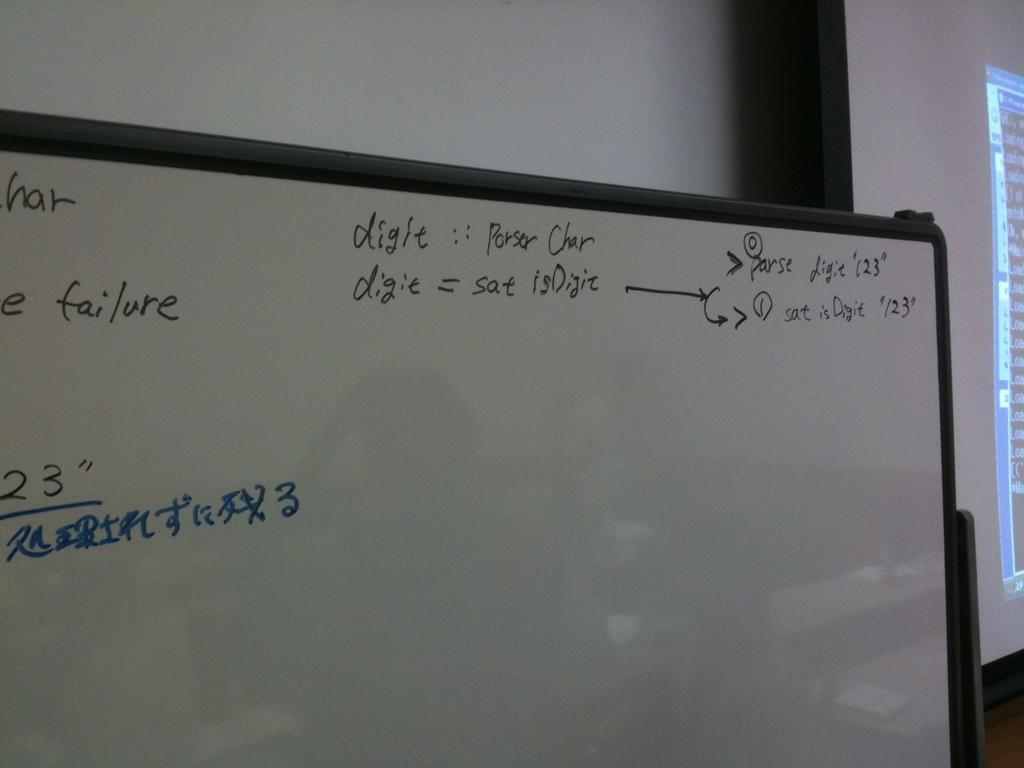<image>
Describe the image concisely. A white board with calculations on it one being digit = sat isDigit. 